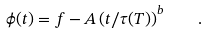Convert formula to latex. <formula><loc_0><loc_0><loc_500><loc_500>\phi ( t ) = f - A \left ( t / \tau ( T ) \right ) ^ { b } \quad .</formula> 